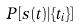Convert formula to latex. <formula><loc_0><loc_0><loc_500><loc_500>P [ s ( t ) | \{ t _ { i } \} ]</formula> 